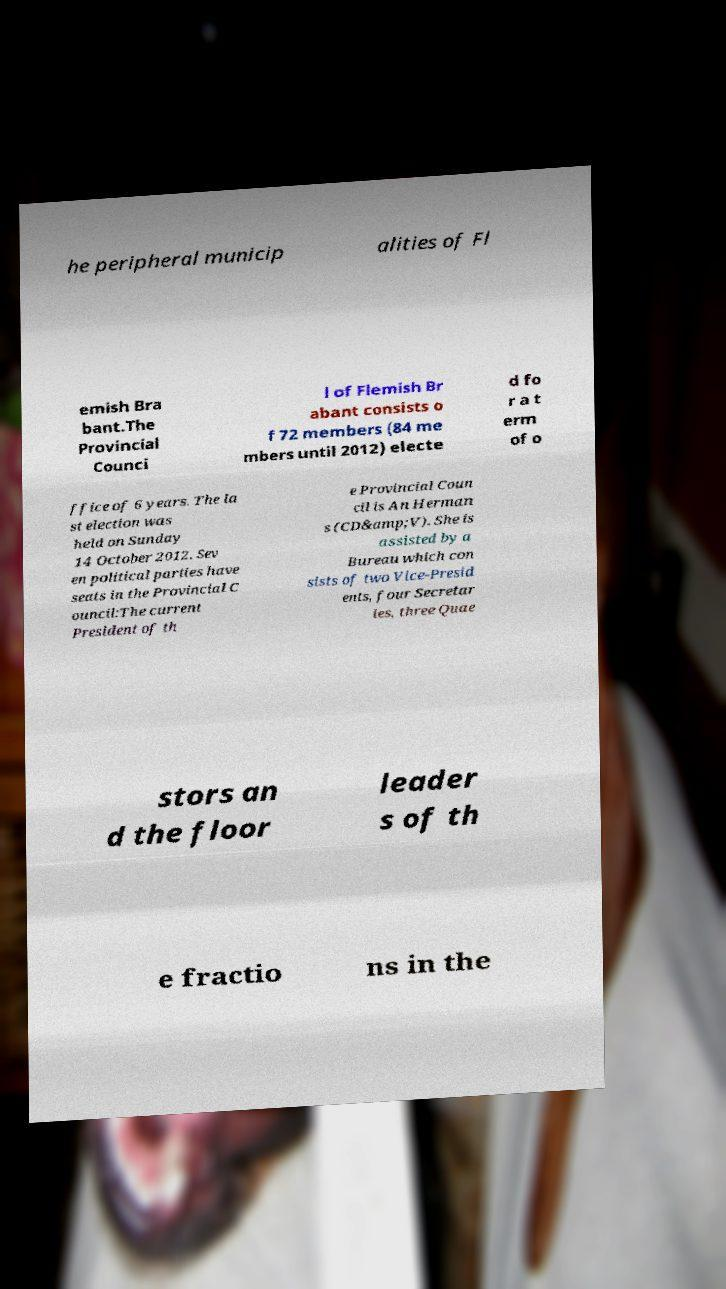Please read and relay the text visible in this image. What does it say? he peripheral municip alities of Fl emish Bra bant.The Provincial Counci l of Flemish Br abant consists o f 72 members (84 me mbers until 2012) electe d fo r a t erm of o ffice of 6 years. The la st election was held on Sunday 14 October 2012. Sev en political parties have seats in the Provincial C ouncil:The current President of th e Provincial Coun cil is An Herman s (CD&amp;V). She is assisted by a Bureau which con sists of two Vice-Presid ents, four Secretar ies, three Quae stors an d the floor leader s of th e fractio ns in the 